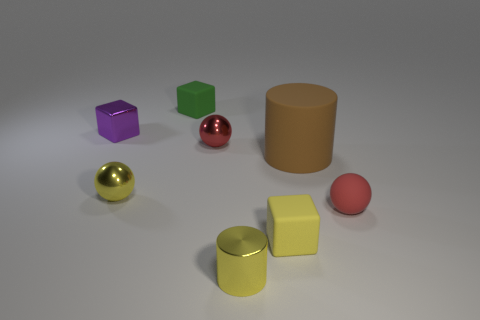Add 2 red things. How many objects exist? 10 Subtract all blocks. How many objects are left? 5 Subtract 1 yellow blocks. How many objects are left? 7 Subtract all large brown cylinders. Subtract all big cylinders. How many objects are left? 6 Add 4 big brown cylinders. How many big brown cylinders are left? 5 Add 7 small metallic blocks. How many small metallic blocks exist? 8 